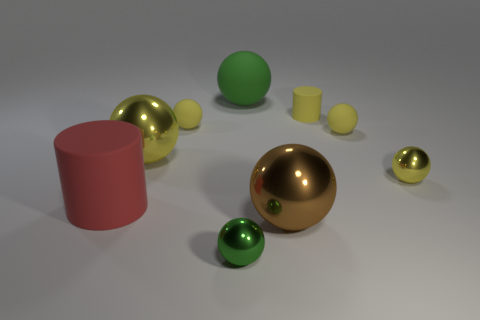Are there more big brown metal balls that are to the right of the brown shiny ball than matte objects behind the big yellow metallic sphere?
Ensure brevity in your answer.  No. Is the shape of the small yellow thing in front of the big yellow shiny thing the same as the small yellow matte object that is to the left of the brown ball?
Give a very brief answer. Yes. What number of other things are there of the same size as the green metallic object?
Your answer should be very brief. 4. What is the size of the red rubber cylinder?
Offer a terse response. Large. Is the material of the cylinder on the left side of the small yellow cylinder the same as the tiny green object?
Keep it short and to the point. No. The large rubber object that is the same shape as the large brown shiny object is what color?
Offer a very short reply. Green. Does the big object to the right of the large green sphere have the same color as the small rubber cylinder?
Offer a terse response. No. Are there any small matte spheres to the left of the small green object?
Offer a terse response. Yes. There is a big sphere that is to the right of the green shiny object and behind the brown object; what color is it?
Your answer should be compact. Green. The small shiny thing that is the same color as the small cylinder is what shape?
Provide a short and direct response. Sphere. 